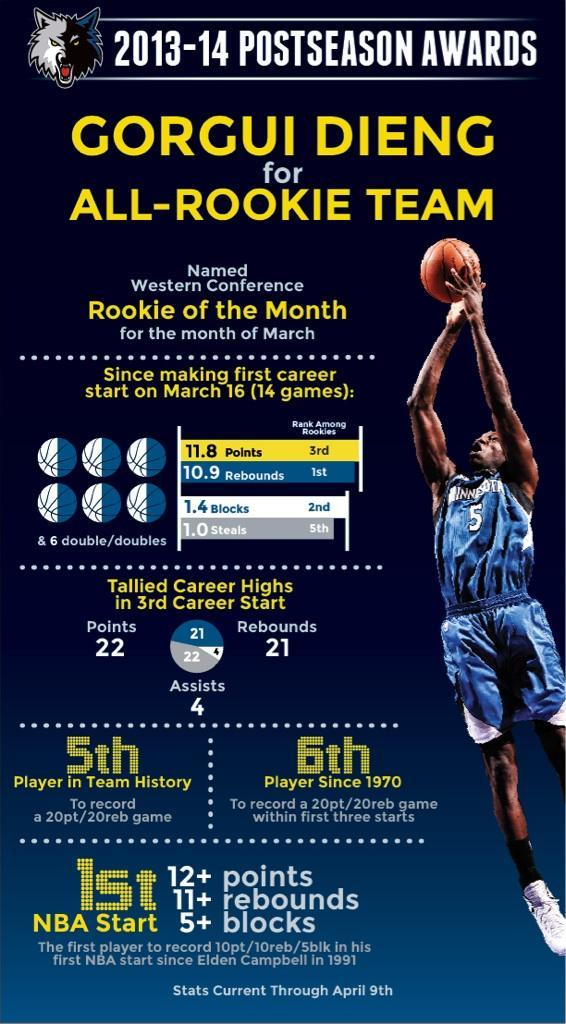Who before him had recorded 10pt/10reb/5blk in his first NBA start
Answer the question with a short phrase. Elden Campbell what is the number on the jersey 5 How many players before him since 1970 had recorded a 20pt/20reb game within first three starts 5 For what does he hold the 1st rank amount rookies rebounds What is his rank about rookies for blocks 2nd How many players before him had recorded 20pt/20reb game 4 